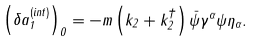<formula> <loc_0><loc_0><loc_500><loc_500>\left ( \delta a _ { 1 } ^ { \left ( i n t \right ) } \right ) _ { 0 } = - m \left ( k _ { 2 } + k _ { 2 } ^ { \dagger } \right ) \bar { \psi } \gamma ^ { \alpha } \psi \eta _ { \alpha } .</formula> 